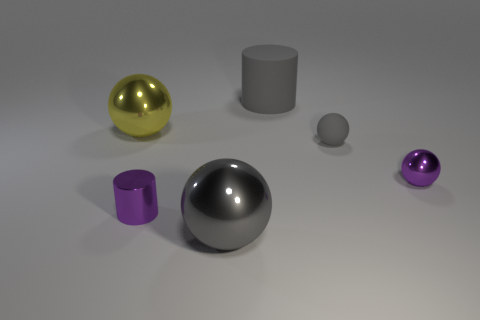Is the number of large cylinders left of the big yellow object the same as the number of purple cylinders?
Provide a short and direct response. No. There is a object on the left side of the purple metallic cylinder; is it the same size as the big gray ball?
Offer a terse response. Yes. What is the color of the other ball that is the same size as the gray rubber sphere?
Your answer should be very brief. Purple. Are there any small purple metal objects in front of the object that is behind the metal sphere left of the gray metal thing?
Ensure brevity in your answer.  Yes. There is a large gray object that is in front of the yellow metallic object; what is it made of?
Offer a terse response. Metal. There is a small gray object; is it the same shape as the object in front of the purple cylinder?
Ensure brevity in your answer.  Yes. Are there an equal number of tiny purple objects behind the small metallic cylinder and large cylinders that are in front of the small purple ball?
Provide a short and direct response. No. What number of other objects are the same material as the tiny gray ball?
Keep it short and to the point. 1. What number of metallic objects are tiny things or tiny cylinders?
Offer a very short reply. 2. Do the big object to the left of the large gray ball and the small gray thing have the same shape?
Keep it short and to the point. Yes. 